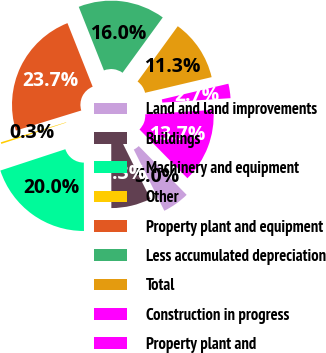Convert chart. <chart><loc_0><loc_0><loc_500><loc_500><pie_chart><fcel>Land and land improvements<fcel>Buildings<fcel>Machinery and equipment<fcel>Other<fcel>Property plant and equipment<fcel>Less accumulated depreciation<fcel>Total<fcel>Construction in progress<fcel>Property plant and<nl><fcel>4.99%<fcel>7.34%<fcel>19.98%<fcel>0.3%<fcel>23.74%<fcel>16.01%<fcel>11.32%<fcel>2.65%<fcel>13.67%<nl></chart> 